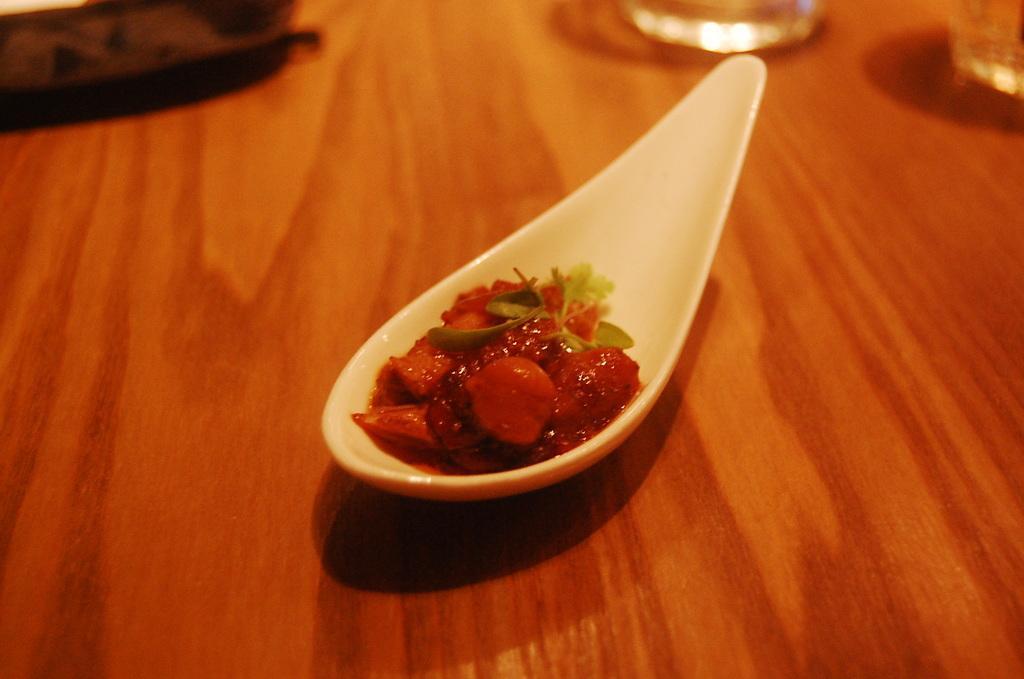Please provide a concise description of this image. In this picture, this is a wooden table on the table there is a spoon with some red color food items and on the table there are glasses and some items also. 